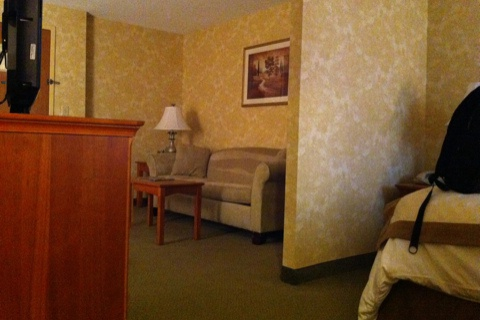Describe the objects in this image and their specific colors. I can see bed in tan, olive, black, and maroon tones, couch in tan, olive, and black tones, couch in tan, maroon, black, and olive tones, tv in tan, black, maroon, and gray tones, and backpack in tan, black, olive, and gray tones in this image. 